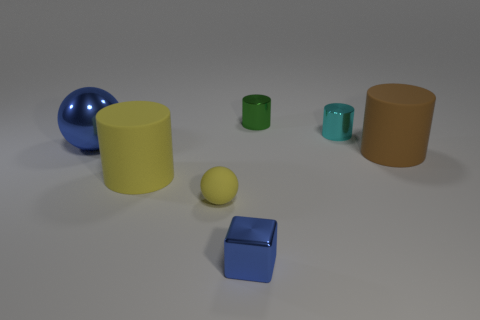There is a blue metallic thing that is to the right of the large blue thing; how big is it?
Offer a terse response. Small. There is a big thing that is to the right of the tiny metallic thing in front of the big blue shiny ball; how many things are on the left side of it?
Provide a short and direct response. 6. Are there any small metallic things on the right side of the tiny blue block?
Your answer should be compact. Yes. How many other things are the same size as the blue metal block?
Your answer should be compact. 3. What material is the cylinder that is in front of the big sphere and left of the big brown rubber cylinder?
Your answer should be compact. Rubber. There is a tiny shiny thing that is in front of the big blue metal sphere; is it the same shape as the matte thing that is to the right of the green cylinder?
Offer a terse response. No. Is there any other thing that is made of the same material as the tiny ball?
Provide a succinct answer. Yes. What is the shape of the metallic thing that is to the left of the large rubber cylinder that is in front of the matte cylinder that is on the right side of the green cylinder?
Provide a short and direct response. Sphere. How many other objects are the same shape as the big metallic object?
Keep it short and to the point. 1. The metallic object that is the same size as the yellow cylinder is what color?
Make the answer very short. Blue. 